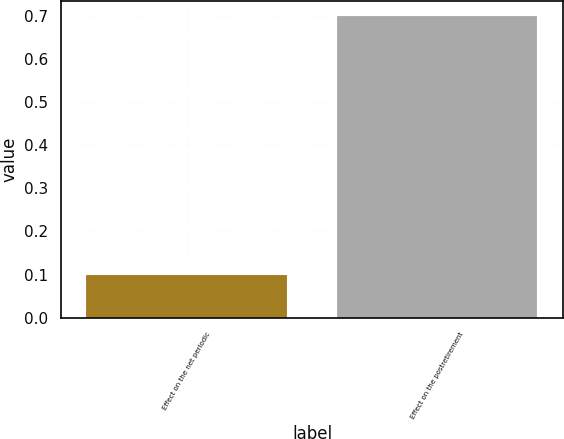<chart> <loc_0><loc_0><loc_500><loc_500><bar_chart><fcel>Effect on the net periodic<fcel>Effect on the postretirement<nl><fcel>0.1<fcel>0.7<nl></chart> 